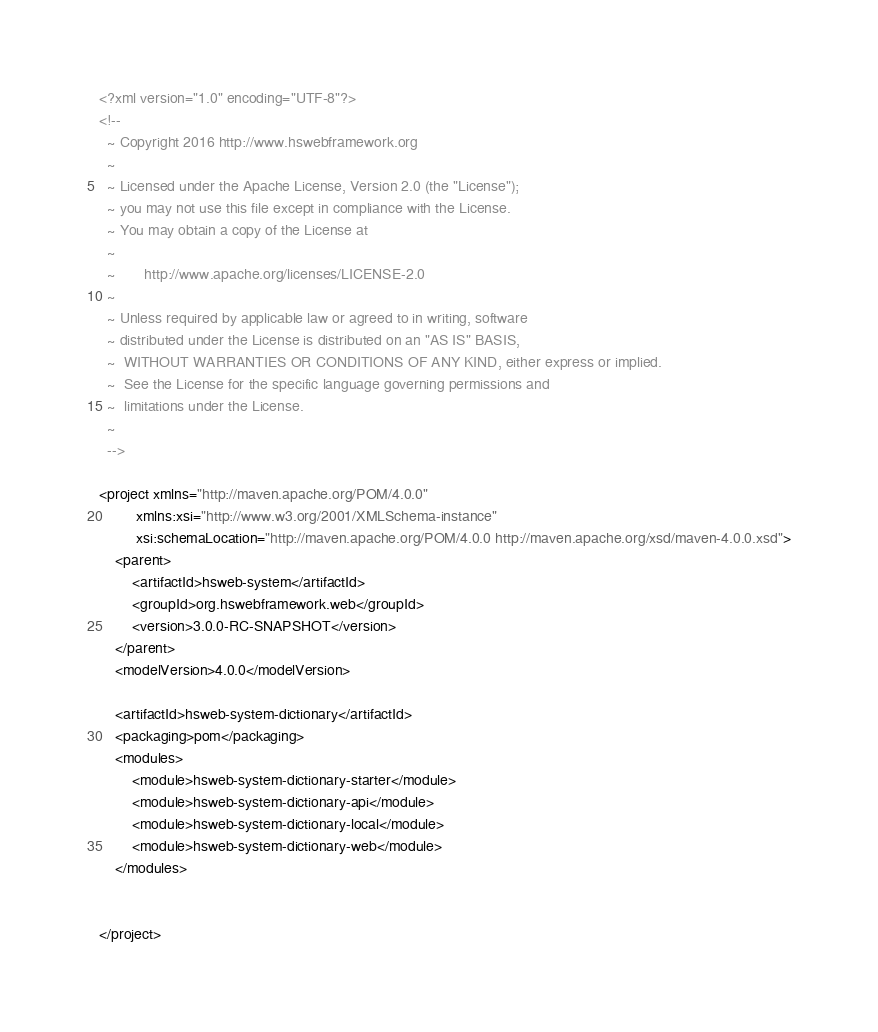<code> <loc_0><loc_0><loc_500><loc_500><_XML_><?xml version="1.0" encoding="UTF-8"?>
<!--
  ~ Copyright 2016 http://www.hswebframework.org
  ~
  ~ Licensed under the Apache License, Version 2.0 (the "License");
  ~ you may not use this file except in compliance with the License.
  ~ You may obtain a copy of the License at
  ~
  ~       http://www.apache.org/licenses/LICENSE-2.0
  ~
  ~ Unless required by applicable law or agreed to in writing, software
  ~ distributed under the License is distributed on an "AS IS" BASIS,
  ~  WITHOUT WARRANTIES OR CONDITIONS OF ANY KIND, either express or implied.
  ~  See the License for the specific language governing permissions and
  ~  limitations under the License.
  ~
  -->

<project xmlns="http://maven.apache.org/POM/4.0.0"
         xmlns:xsi="http://www.w3.org/2001/XMLSchema-instance"
         xsi:schemaLocation="http://maven.apache.org/POM/4.0.0 http://maven.apache.org/xsd/maven-4.0.0.xsd">
    <parent>
        <artifactId>hsweb-system</artifactId>
        <groupId>org.hswebframework.web</groupId>
        <version>3.0.0-RC-SNAPSHOT</version>
    </parent>
    <modelVersion>4.0.0</modelVersion>

    <artifactId>hsweb-system-dictionary</artifactId>
    <packaging>pom</packaging>
    <modules>
        <module>hsweb-system-dictionary-starter</module>
        <module>hsweb-system-dictionary-api</module>
        <module>hsweb-system-dictionary-local</module>
        <module>hsweb-system-dictionary-web</module>
    </modules>


</project></code> 